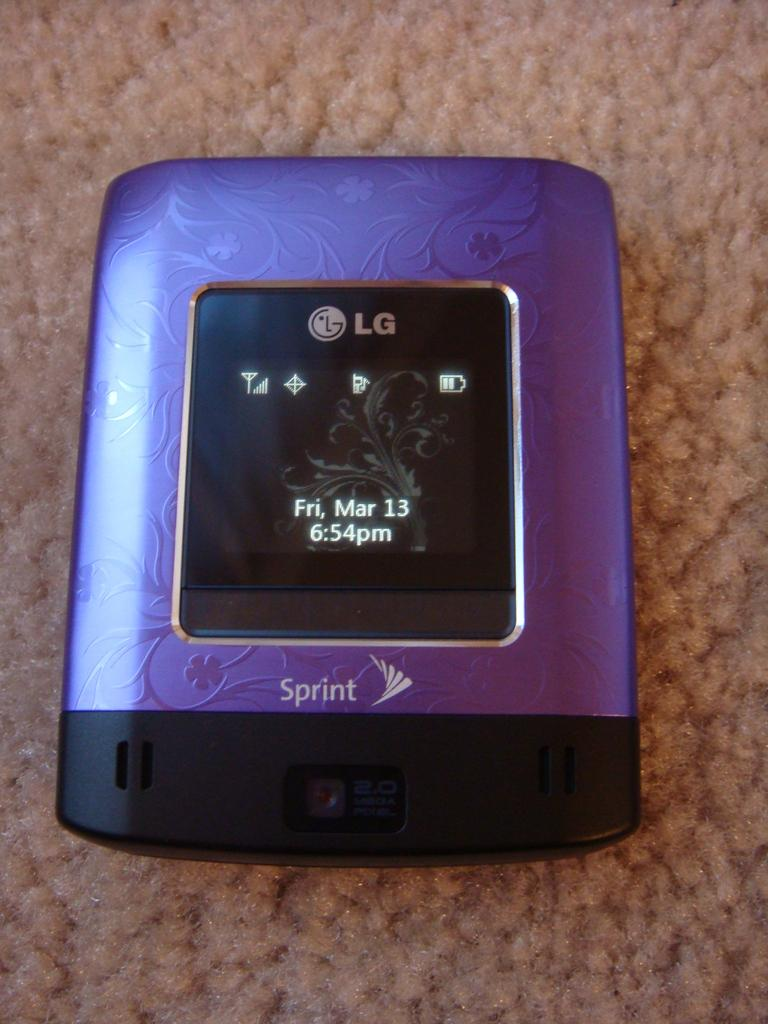<image>
Give a short and clear explanation of the subsequent image. A purple Spring device made by LG with a display screen and 2 mega pixel camera on the bottom. 